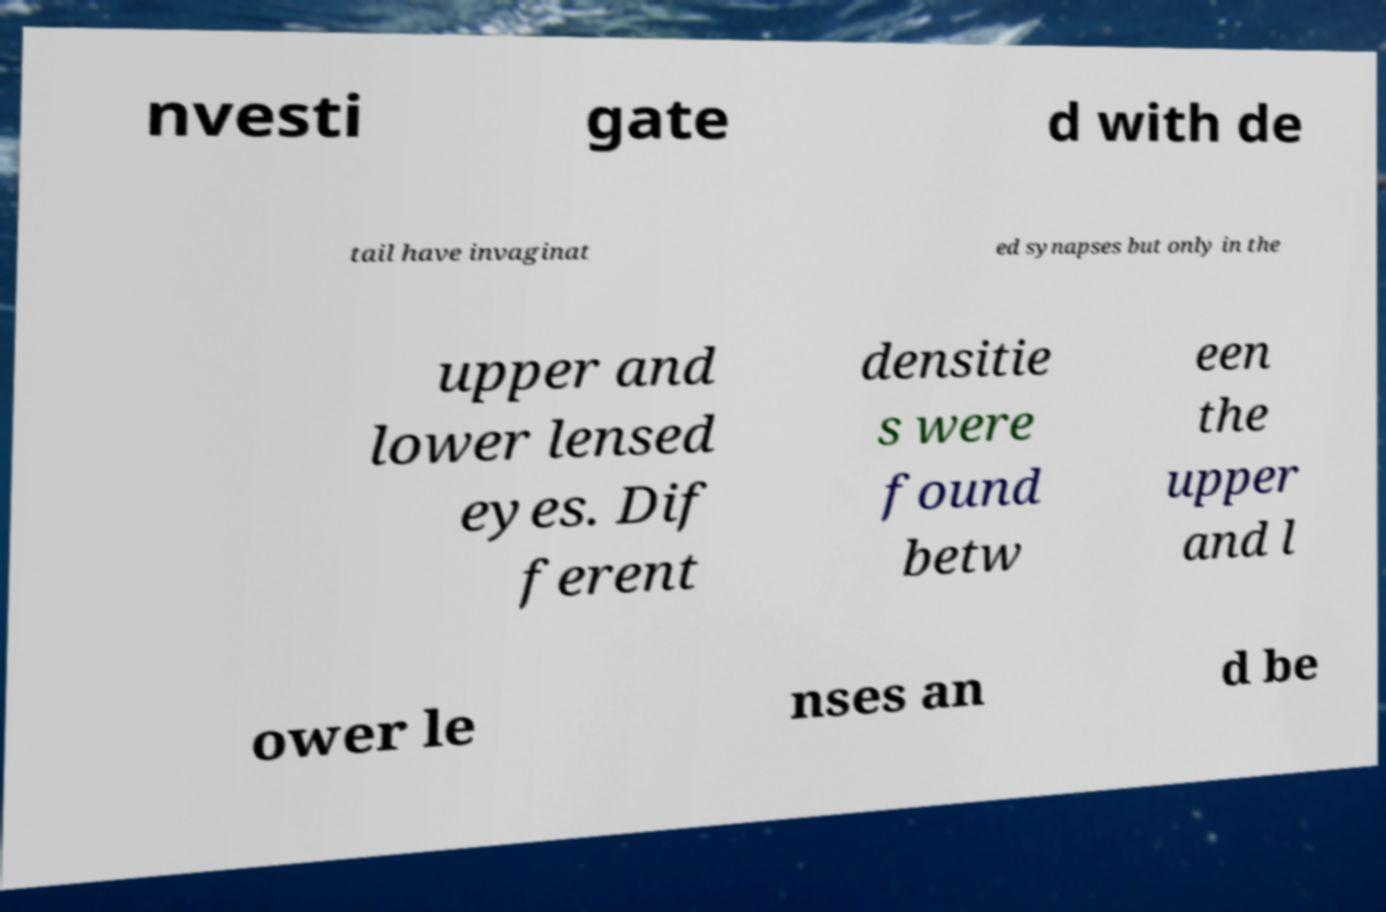There's text embedded in this image that I need extracted. Can you transcribe it verbatim? nvesti gate d with de tail have invaginat ed synapses but only in the upper and lower lensed eyes. Dif ferent densitie s were found betw een the upper and l ower le nses an d be 